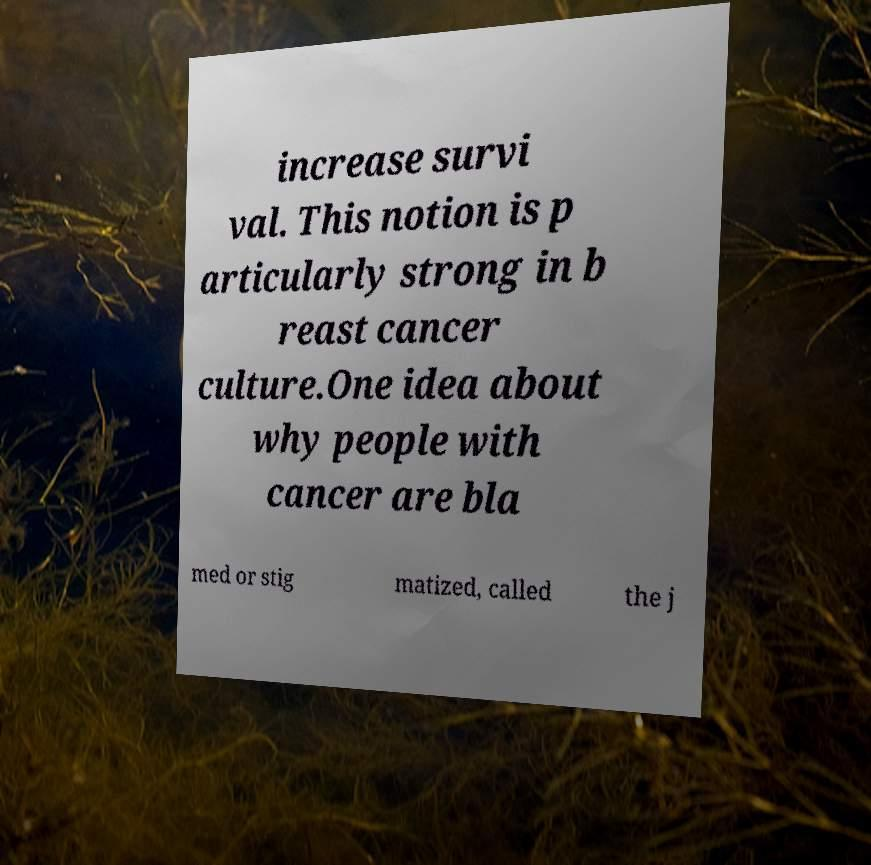I need the written content from this picture converted into text. Can you do that? increase survi val. This notion is p articularly strong in b reast cancer culture.One idea about why people with cancer are bla med or stig matized, called the j 